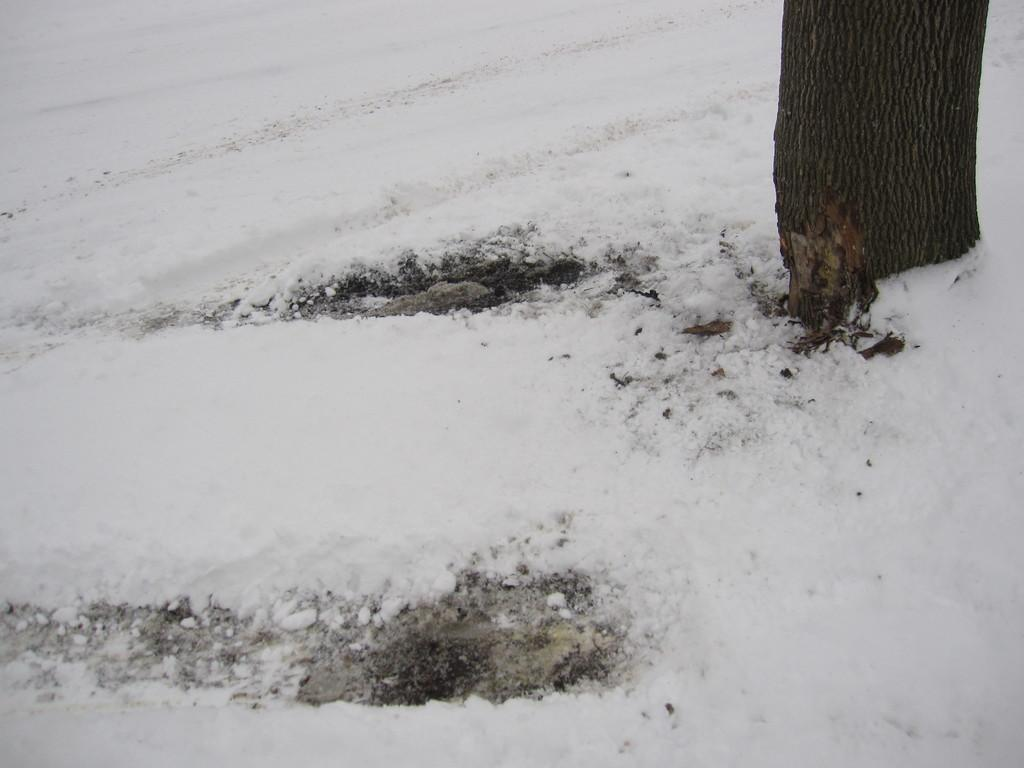What is covering the ground in the image? There is snow on the ground in the image. What type of vegetation can be seen in the image? There is a tree on the right side of the image. How does the ring fit into the image? There is no ring present in the image. What type of work is the farmer doing in the image? There is no farmer present in the image. 